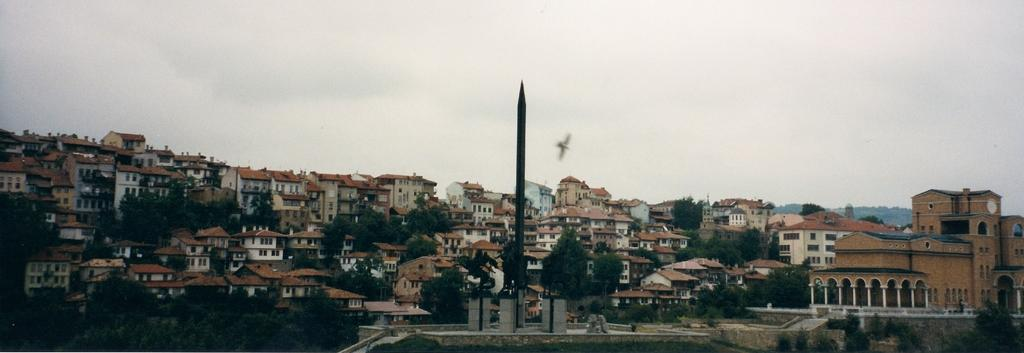What is the main subject of the image? There is a bird flying in the image. What else can be seen in the image besides the bird? There are many buildings and trees in the image. How would you describe the sky in the image? The sky is cloudy in the image. What type of rice is being cooked in the image? There is no rice present in the image; it features a bird flying among buildings and trees with a cloudy sky. 